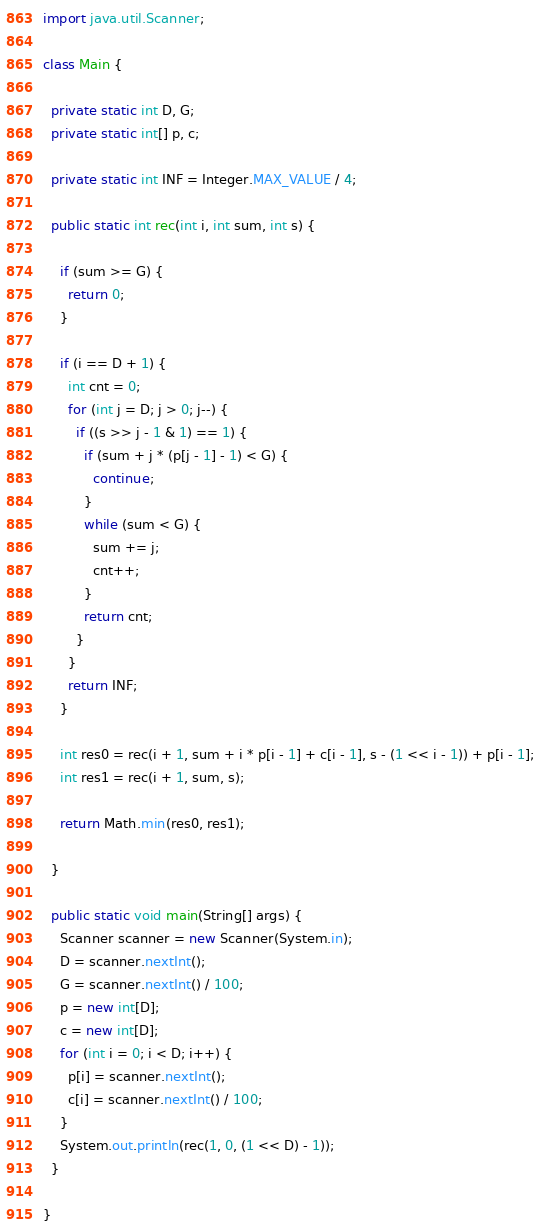Convert code to text. <code><loc_0><loc_0><loc_500><loc_500><_Java_>import java.util.Scanner;

class Main {

  private static int D, G;
  private static int[] p, c;

  private static int INF = Integer.MAX_VALUE / 4;

  public static int rec(int i, int sum, int s) {

    if (sum >= G) {
      return 0;
    }

    if (i == D + 1) {
      int cnt = 0;
      for (int j = D; j > 0; j--) {
        if ((s >> j - 1 & 1) == 1) {
          if (sum + j * (p[j - 1] - 1) < G) {
            continue;
          }
          while (sum < G) {
            sum += j;
            cnt++;
          }
          return cnt;
        }
      }
      return INF;
    }

    int res0 = rec(i + 1, sum + i * p[i - 1] + c[i - 1], s - (1 << i - 1)) + p[i - 1];
    int res1 = rec(i + 1, sum, s);

    return Math.min(res0, res1);

  }

  public static void main(String[] args) {
    Scanner scanner = new Scanner(System.in);
    D = scanner.nextInt();
    G = scanner.nextInt() / 100;
    p = new int[D];
    c = new int[D];
    for (int i = 0; i < D; i++) {
      p[i] = scanner.nextInt();
      c[i] = scanner.nextInt() / 100;
    }
    System.out.println(rec(1, 0, (1 << D) - 1));
  }

}
</code> 